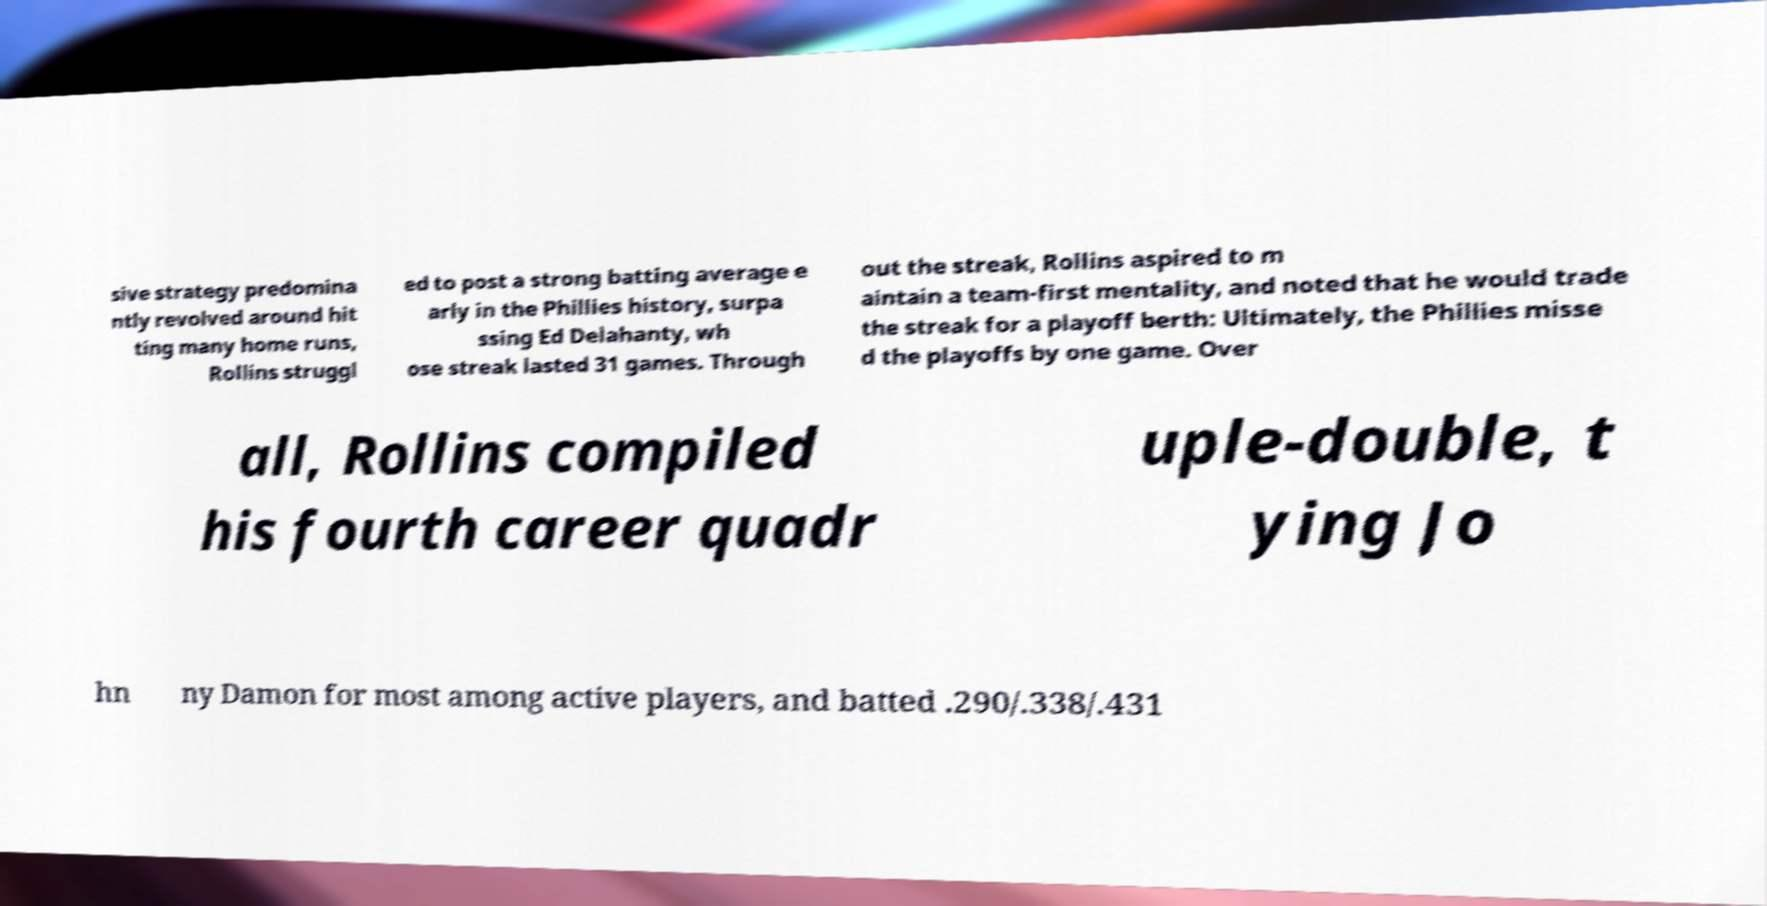Please identify and transcribe the text found in this image. sive strategy predomina ntly revolved around hit ting many home runs, Rollins struggl ed to post a strong batting average e arly in the Phillies history, surpa ssing Ed Delahanty, wh ose streak lasted 31 games. Through out the streak, Rollins aspired to m aintain a team-first mentality, and noted that he would trade the streak for a playoff berth: Ultimately, the Phillies misse d the playoffs by one game. Over all, Rollins compiled his fourth career quadr uple-double, t ying Jo hn ny Damon for most among active players, and batted .290/.338/.431 